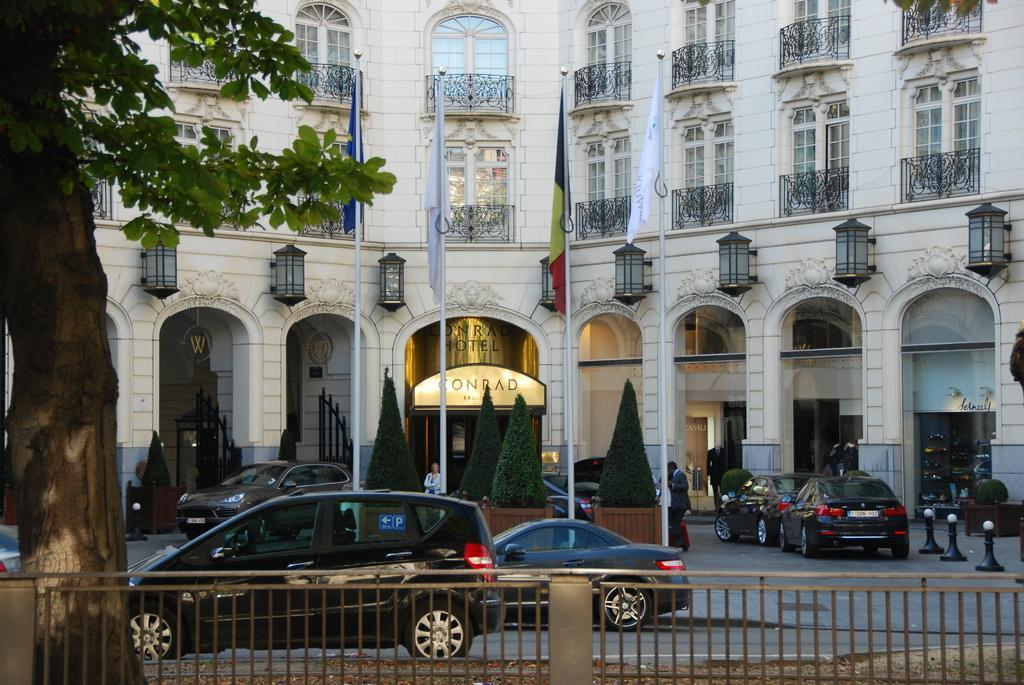Can you describe this image briefly? In this image I can see the rail. I can see the vehicles on the road. I can also see the flags. In the background, I can see the trees and the building. 